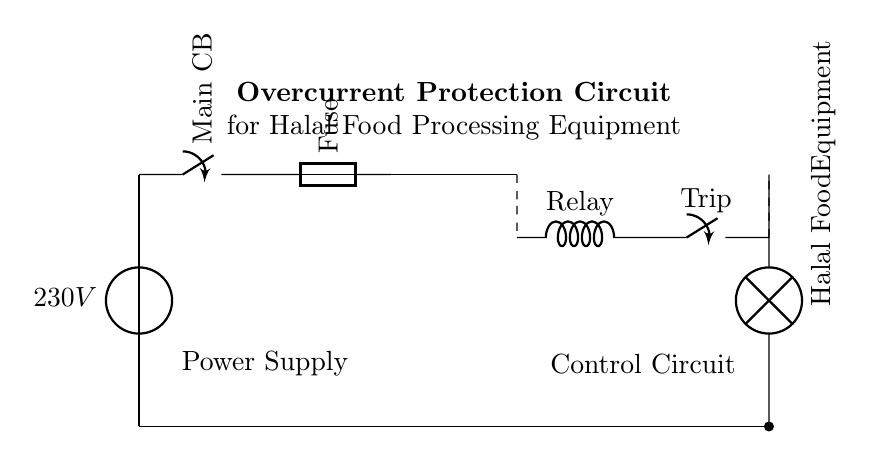What is the voltage of the power source? The voltage is specified next to the power source symbol, which shows a value of 230V. This indicates the potential difference supplied to the circuit.
Answer: 230V What type of protective device is used in this circuit? The protective devices present in the circuit include a main circuit breaker and a fuse, which are vital for overcurrent protection. The circuit breaker is located after the power source, and the fuse follows it.
Answer: Circuit breaker and fuse What is the function of the current transformer? The current transformer is shown in the circuit as the component connecting the fuse to the overcurrent relay. Its function is to sense the current flowing through the circuit and provide an input to the relay for monitoring.
Answer: Current sensing What happens when the relay is activated? The relay controls a trip switch that disconnects power from the load when overcurrent is detected. This is crucial for preventing damage or hazards in the Halal food processing equipment.
Answer: Power is disconnected What is the connection type of the load? The load, represented as the Halal food processing equipment, is connected in parallel with the circuit components, receiving direct voltage from the power supply through the closing switch.
Answer: Parallel connection How does the overcurrent protection circuit contribute to food safety? The circuit prevents excessive current draw, which can lead to equipment overheating or failure. This is crucial for maintaining safe operating conditions in food processing, ensuring the integrity and safety of halal food production.
Answer: Maintains safety 